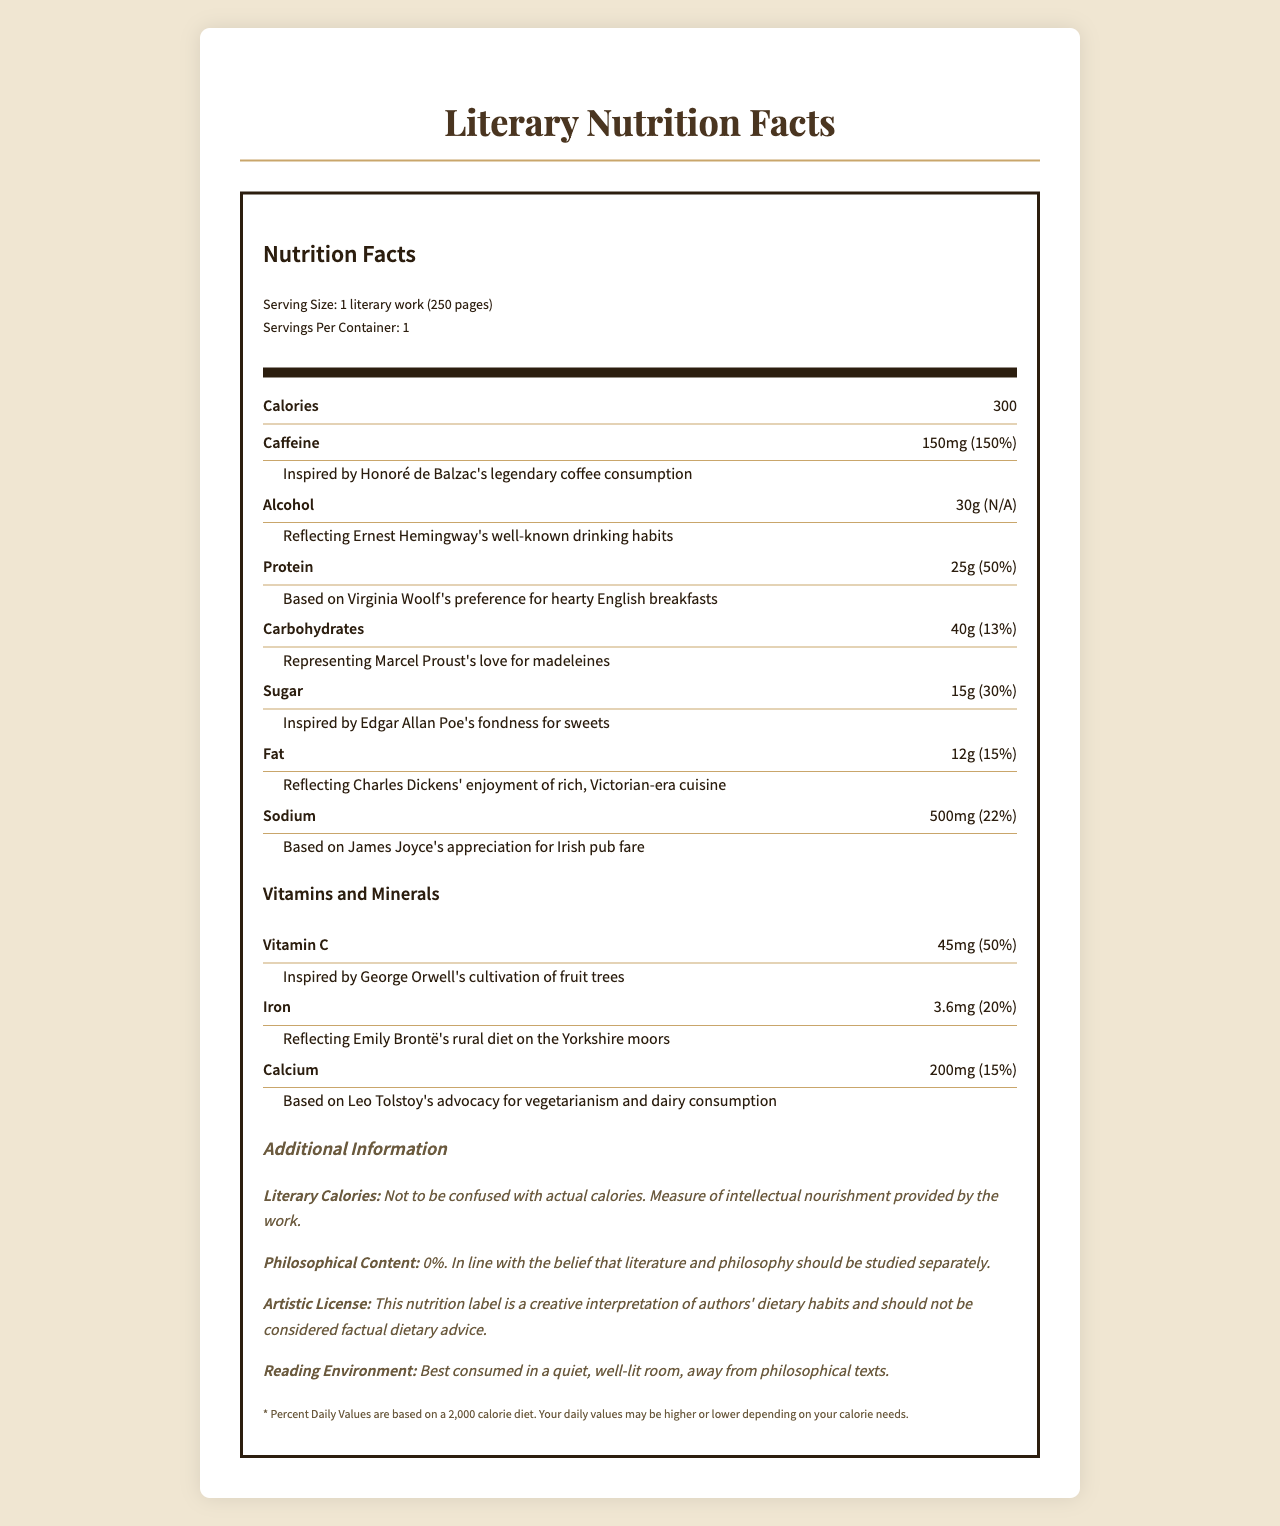what is the serving size of the literary work? The serving size is mentioned at the top as "Serving Size: 1 literary work (250 pages)".
Answer: 1 literary work (250 pages) how much caffeine does one literary work contain? The label states that one literary work contains 150mg of Caffeine.
Answer: 150mg how much protein is provided per literary work? The nutritional information lists Protein at 25g per serving.
Answer: 25g what is the source of the literary representation of carbohydrates? The description for Carbohydrates mentions it is represented by Marcel Proust's love for madeleines.
Answer: Marcel Proust's love for madeleines which nutrient has the highest daily value percentage? Among all the listed nutrients, Caffeine has the highest daily value percentage at 150%.
Answer: Caffeine, 150% what is the daily value of Vitamin C per serving? Under the Vitamins and Minerals section, Vitamin C is listed with a daily value of 50%.
Answer: 50% reflecting whose dietary habit is alcohol included? The label specifies that Alcohol is included reflecting Ernest Hemingway's well-known drinking habits.
Answer: Ernest Hemingway what is the amount of fat provided per serving? The nutritional information lists Fat at 12g per serving.
Answer: 12g what is the main idea of the document? The document is styled as a nutrition facts label, assigning various nutrients and minerals inspired by the dietary preferences of famous authors. It also includes additional info about literary calories, philosophical content, and the best reading environment.
Answer: The document creatively interprets the dietary habits of renowned authors as nutrition facts for a literary work. philosophical content percentage per serving is... The document states that the philosophical content is 0%.
Answer: 0% how many calories are there per serving? A. 250 B. 300 C. 350 The document lists the calories per serving as 300.
Answer: B what inspired the inclusion of Iron in the label? A. George Orwell's gardening habits B. Emily Brontë's rural diet C. Leo Tolstoy's vegetarianism The label mentions that the inclusion of Iron reflects Emily Brontë's rural diet on the Yorkshire moors.
Answer: B how much sugar is present per serving? A. 10g B. 15g C. 20g D. 25g The label indicates that there is 15g of sugar per serving.
Answer: B is there any artistic license mentioned on the label? The additional information section mentions an "Artistic License," stating it is a creative interpretation and not factual dietary advice.
Answer: Yes how is the reading environment best described? The additional info section advises that the reading environment is best consumed in a quiet, well-lit room, away from philosophical texts.
Answer: Best consumed in a quiet, well-lit room, away from philosophical texts. what is the actual dietary habit represented by Virginia Woolf? The label only mentions that Protein is inspired by Virginia Woolf's preference for hearty English breakfasts, but doesn't provide further factual details about her actual dietary habits.
Answer: Cannot be determined 